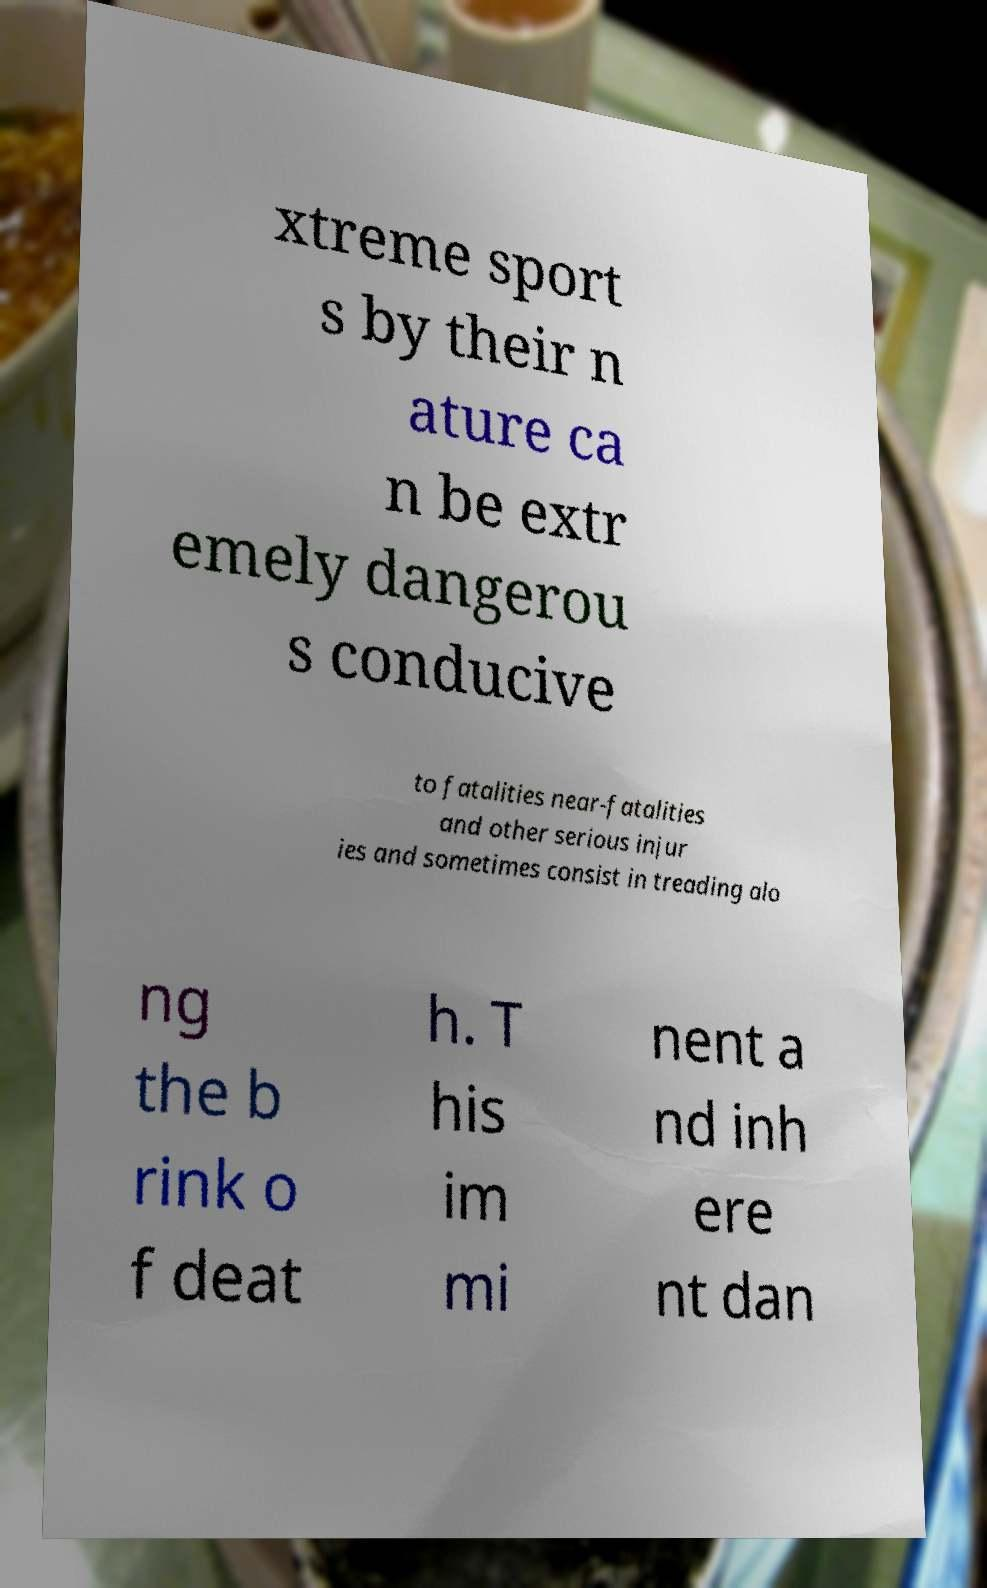I need the written content from this picture converted into text. Can you do that? xtreme sport s by their n ature ca n be extr emely dangerou s conducive to fatalities near-fatalities and other serious injur ies and sometimes consist in treading alo ng the b rink o f deat h. T his im mi nent a nd inh ere nt dan 